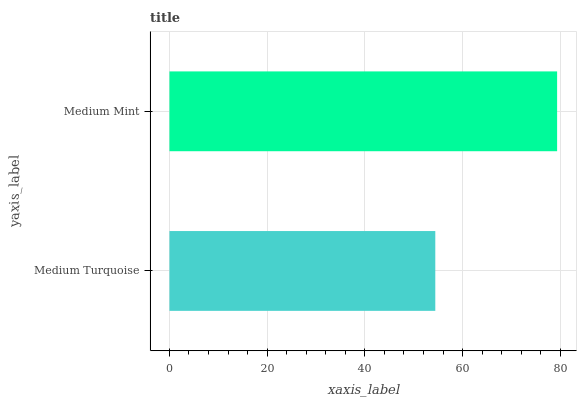Is Medium Turquoise the minimum?
Answer yes or no. Yes. Is Medium Mint the maximum?
Answer yes or no. Yes. Is Medium Mint the minimum?
Answer yes or no. No. Is Medium Mint greater than Medium Turquoise?
Answer yes or no. Yes. Is Medium Turquoise less than Medium Mint?
Answer yes or no. Yes. Is Medium Turquoise greater than Medium Mint?
Answer yes or no. No. Is Medium Mint less than Medium Turquoise?
Answer yes or no. No. Is Medium Mint the high median?
Answer yes or no. Yes. Is Medium Turquoise the low median?
Answer yes or no. Yes. Is Medium Turquoise the high median?
Answer yes or no. No. Is Medium Mint the low median?
Answer yes or no. No. 